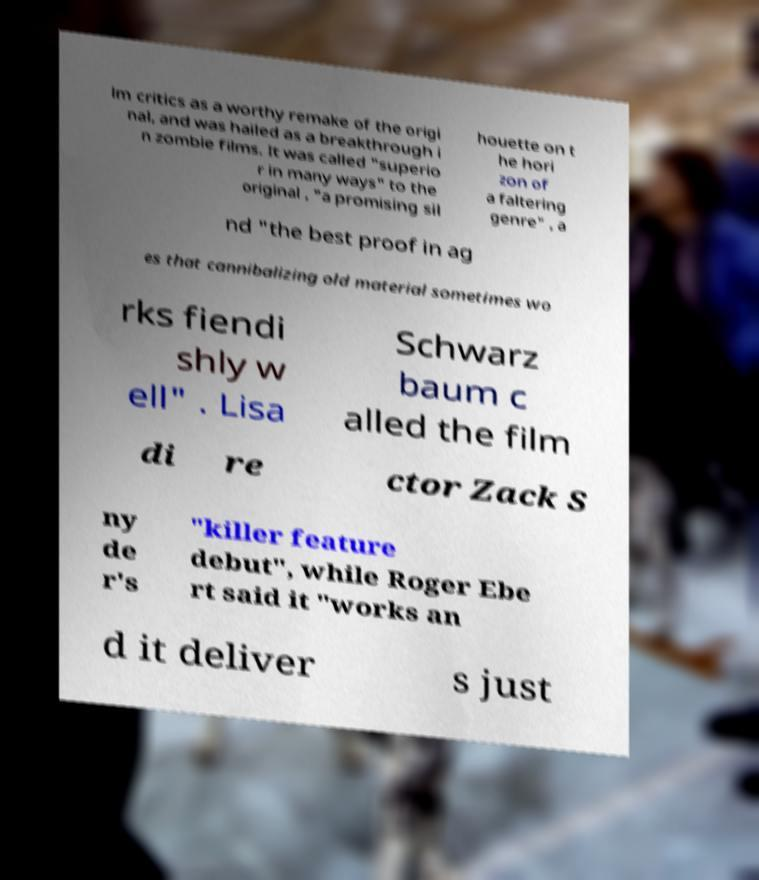Can you read and provide the text displayed in the image?This photo seems to have some interesting text. Can you extract and type it out for me? lm critics as a worthy remake of the origi nal, and was hailed as a breakthrough i n zombie films. It was called "superio r in many ways" to the original , "a promising sil houette on t he hori zon of a faltering genre" , a nd "the best proof in ag es that cannibalizing old material sometimes wo rks fiendi shly w ell" . Lisa Schwarz baum c alled the film di re ctor Zack S ny de r's "killer feature debut", while Roger Ebe rt said it "works an d it deliver s just 